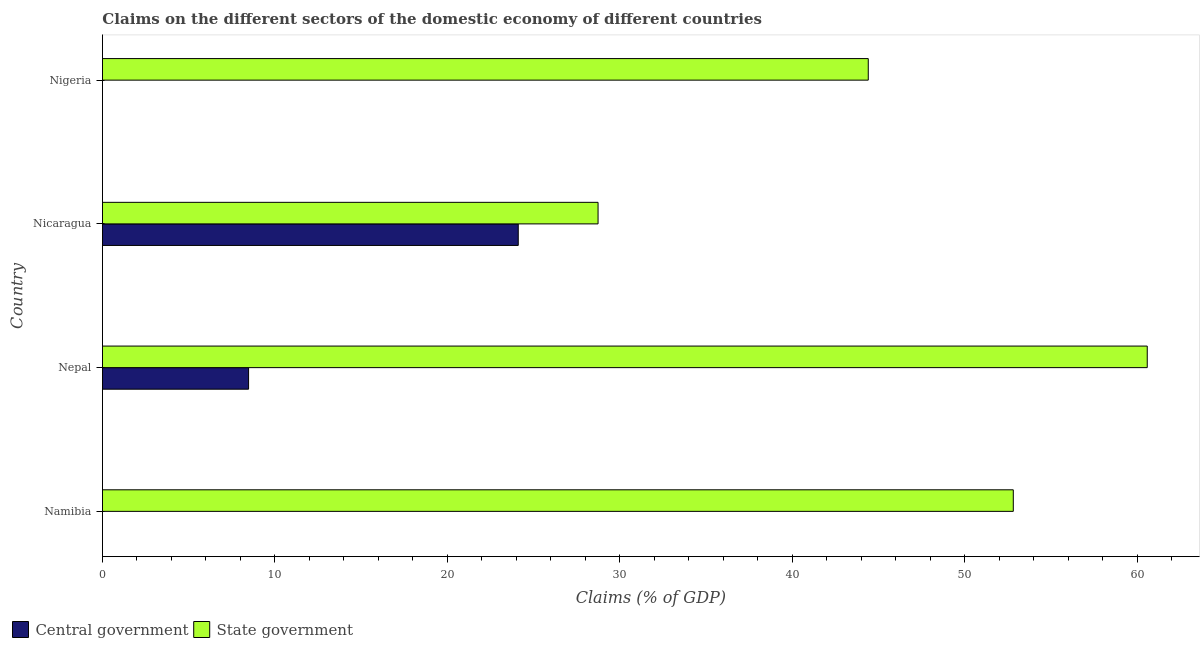How many different coloured bars are there?
Ensure brevity in your answer.  2. How many bars are there on the 2nd tick from the bottom?
Provide a succinct answer. 2. What is the label of the 4th group of bars from the top?
Provide a short and direct response. Namibia. What is the claims on state government in Nigeria?
Your answer should be compact. 44.41. Across all countries, what is the maximum claims on central government?
Your answer should be very brief. 24.11. Across all countries, what is the minimum claims on state government?
Offer a very short reply. 28.74. In which country was the claims on state government maximum?
Ensure brevity in your answer.  Nepal. What is the total claims on central government in the graph?
Provide a succinct answer. 32.59. What is the difference between the claims on state government in Namibia and that in Nepal?
Your response must be concise. -7.77. What is the difference between the claims on state government in Nigeria and the claims on central government in Nepal?
Offer a very short reply. 35.94. What is the average claims on central government per country?
Offer a terse response. 8.15. What is the difference between the claims on state government and claims on central government in Nicaragua?
Offer a very short reply. 4.63. In how many countries, is the claims on state government greater than 8 %?
Provide a short and direct response. 4. What is the ratio of the claims on state government in Nepal to that in Nigeria?
Provide a short and direct response. 1.36. Is the claims on state government in Nepal less than that in Nicaragua?
Provide a succinct answer. No. What is the difference between the highest and the second highest claims on state government?
Your response must be concise. 7.77. What is the difference between the highest and the lowest claims on central government?
Your response must be concise. 24.11. Does the graph contain any zero values?
Provide a short and direct response. Yes. Does the graph contain grids?
Offer a very short reply. No. Where does the legend appear in the graph?
Provide a short and direct response. Bottom left. What is the title of the graph?
Ensure brevity in your answer.  Claims on the different sectors of the domestic economy of different countries. What is the label or title of the X-axis?
Provide a short and direct response. Claims (% of GDP). What is the label or title of the Y-axis?
Provide a short and direct response. Country. What is the Claims (% of GDP) in State government in Namibia?
Give a very brief answer. 52.82. What is the Claims (% of GDP) of Central government in Nepal?
Your response must be concise. 8.47. What is the Claims (% of GDP) of State government in Nepal?
Your answer should be compact. 60.59. What is the Claims (% of GDP) in Central government in Nicaragua?
Your answer should be compact. 24.11. What is the Claims (% of GDP) in State government in Nicaragua?
Offer a terse response. 28.74. What is the Claims (% of GDP) in Central government in Nigeria?
Provide a succinct answer. 0. What is the Claims (% of GDP) in State government in Nigeria?
Your answer should be very brief. 44.41. Across all countries, what is the maximum Claims (% of GDP) of Central government?
Keep it short and to the point. 24.11. Across all countries, what is the maximum Claims (% of GDP) in State government?
Offer a terse response. 60.59. Across all countries, what is the minimum Claims (% of GDP) in State government?
Ensure brevity in your answer.  28.74. What is the total Claims (% of GDP) of Central government in the graph?
Offer a very short reply. 32.59. What is the total Claims (% of GDP) in State government in the graph?
Your answer should be very brief. 186.57. What is the difference between the Claims (% of GDP) of State government in Namibia and that in Nepal?
Offer a very short reply. -7.77. What is the difference between the Claims (% of GDP) in State government in Namibia and that in Nicaragua?
Your response must be concise. 24.08. What is the difference between the Claims (% of GDP) of State government in Namibia and that in Nigeria?
Ensure brevity in your answer.  8.41. What is the difference between the Claims (% of GDP) in Central government in Nepal and that in Nicaragua?
Keep it short and to the point. -15.64. What is the difference between the Claims (% of GDP) in State government in Nepal and that in Nicaragua?
Offer a terse response. 31.85. What is the difference between the Claims (% of GDP) in State government in Nepal and that in Nigeria?
Your answer should be compact. 16.18. What is the difference between the Claims (% of GDP) in State government in Nicaragua and that in Nigeria?
Keep it short and to the point. -15.67. What is the difference between the Claims (% of GDP) of Central government in Nepal and the Claims (% of GDP) of State government in Nicaragua?
Give a very brief answer. -20.27. What is the difference between the Claims (% of GDP) in Central government in Nepal and the Claims (% of GDP) in State government in Nigeria?
Ensure brevity in your answer.  -35.94. What is the difference between the Claims (% of GDP) in Central government in Nicaragua and the Claims (% of GDP) in State government in Nigeria?
Provide a succinct answer. -20.3. What is the average Claims (% of GDP) of Central government per country?
Give a very brief answer. 8.15. What is the average Claims (% of GDP) of State government per country?
Your response must be concise. 46.64. What is the difference between the Claims (% of GDP) in Central government and Claims (% of GDP) in State government in Nepal?
Give a very brief answer. -52.12. What is the difference between the Claims (% of GDP) of Central government and Claims (% of GDP) of State government in Nicaragua?
Your answer should be compact. -4.63. What is the ratio of the Claims (% of GDP) in State government in Namibia to that in Nepal?
Keep it short and to the point. 0.87. What is the ratio of the Claims (% of GDP) of State government in Namibia to that in Nicaragua?
Your answer should be compact. 1.84. What is the ratio of the Claims (% of GDP) in State government in Namibia to that in Nigeria?
Offer a terse response. 1.19. What is the ratio of the Claims (% of GDP) in Central government in Nepal to that in Nicaragua?
Your response must be concise. 0.35. What is the ratio of the Claims (% of GDP) in State government in Nepal to that in Nicaragua?
Your answer should be compact. 2.11. What is the ratio of the Claims (% of GDP) of State government in Nepal to that in Nigeria?
Your answer should be compact. 1.36. What is the ratio of the Claims (% of GDP) of State government in Nicaragua to that in Nigeria?
Provide a succinct answer. 0.65. What is the difference between the highest and the second highest Claims (% of GDP) in State government?
Provide a short and direct response. 7.77. What is the difference between the highest and the lowest Claims (% of GDP) in Central government?
Make the answer very short. 24.11. What is the difference between the highest and the lowest Claims (% of GDP) of State government?
Give a very brief answer. 31.85. 